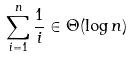<formula> <loc_0><loc_0><loc_500><loc_500>\sum _ { i = 1 } ^ { n } \frac { 1 } { i } \in \Theta ( \log n )</formula> 